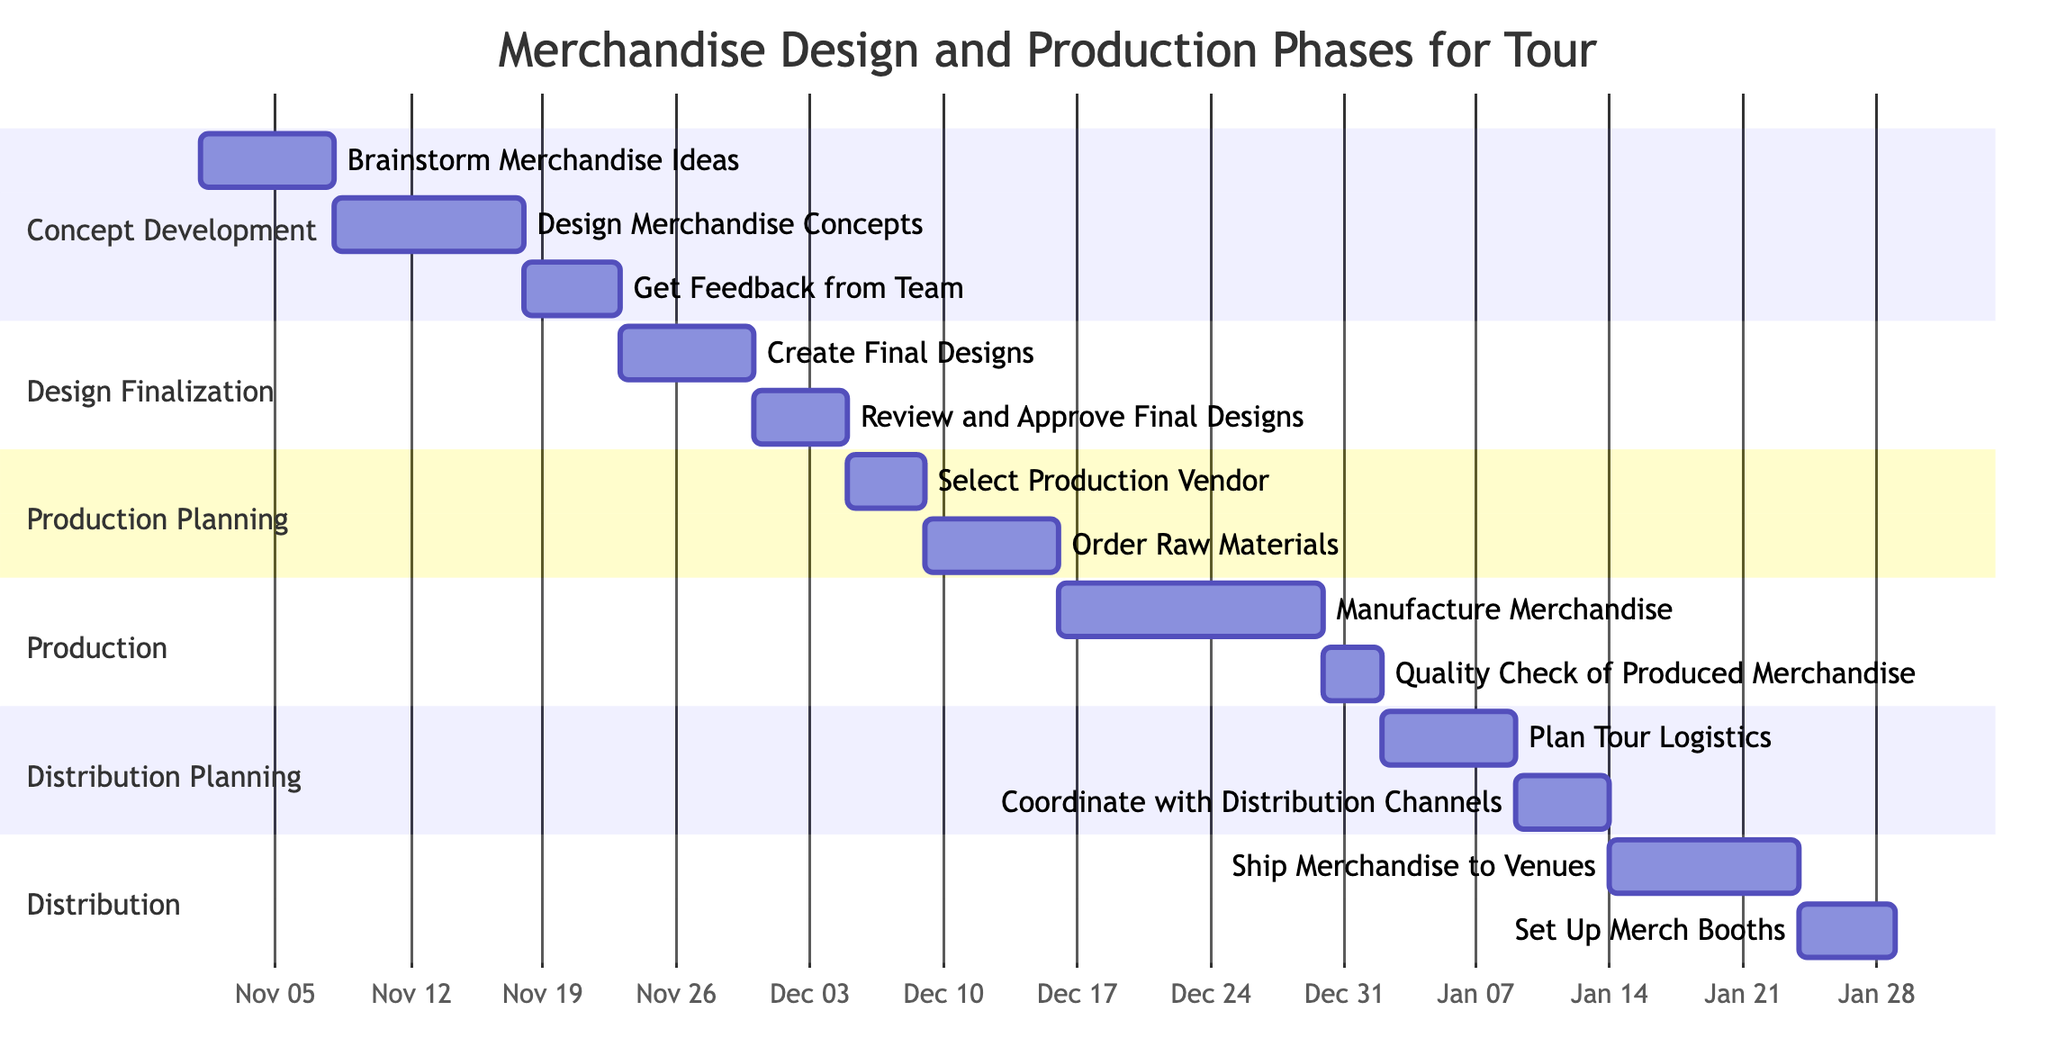What is the duration of the "Get Feedback from Team" task? The task "Get Feedback from Team" has a duration of 5 days, as indicated directly next to the task node in the diagram.
Answer: 5 days How many tasks are there in the "Design Finalization" phase? The "Design Finalization" phase contains 2 tasks: "Create Final Designs" and "Review and Approve Final Designs." Counting these gives a total of 2 tasks.
Answer: 2 What task follows "Order Raw Materials"? The task "Manufacture Merchandise" directly follows "Order Raw Materials," as it is the next task listed after the completion of the ordering process.
Answer: Manufacture Merchandise Which phase begins on January 3, 2024? The phase that begins on January 3, 2024, is "Distribution Planning," as shown in the start time for that section in the diagram.
Answer: Distribution Planning What is the total duration for the "Production" phase? The "Production" phase consists of two tasks: "Manufacture Merchandise" (14 days) and "Quality Check of Produced Merchandise" (3 days). The total duration is the sum of these two values, which results in 17 days.
Answer: 17 days Which task has the earliest start date? The earliest start date is for the task "Brainstorm Merchandise Ideas," which starts on November 1, 2023, making it the first task in the entire project timeline.
Answer: Brainstorm Merchandise Ideas How many days are allocated for "Ship Merchandise to Venues"? The task "Ship Merchandise to Venues" is allocated 10 days for its completion, as stated next to the task in the diagram.
Answer: 10 days What phase occurs directly after "Design Finalization"? The phase that occurs directly after "Design Finalization" is "Production Planning," indicated by the flow following the final design approval tasks.
Answer: Production Planning Which task ends on January 25, 2024? The task that ends on January 25, 2024, is "Set Up Merch Booths," as its duration leads to this end date in the timeline.
Answer: Set Up Merch Booths 